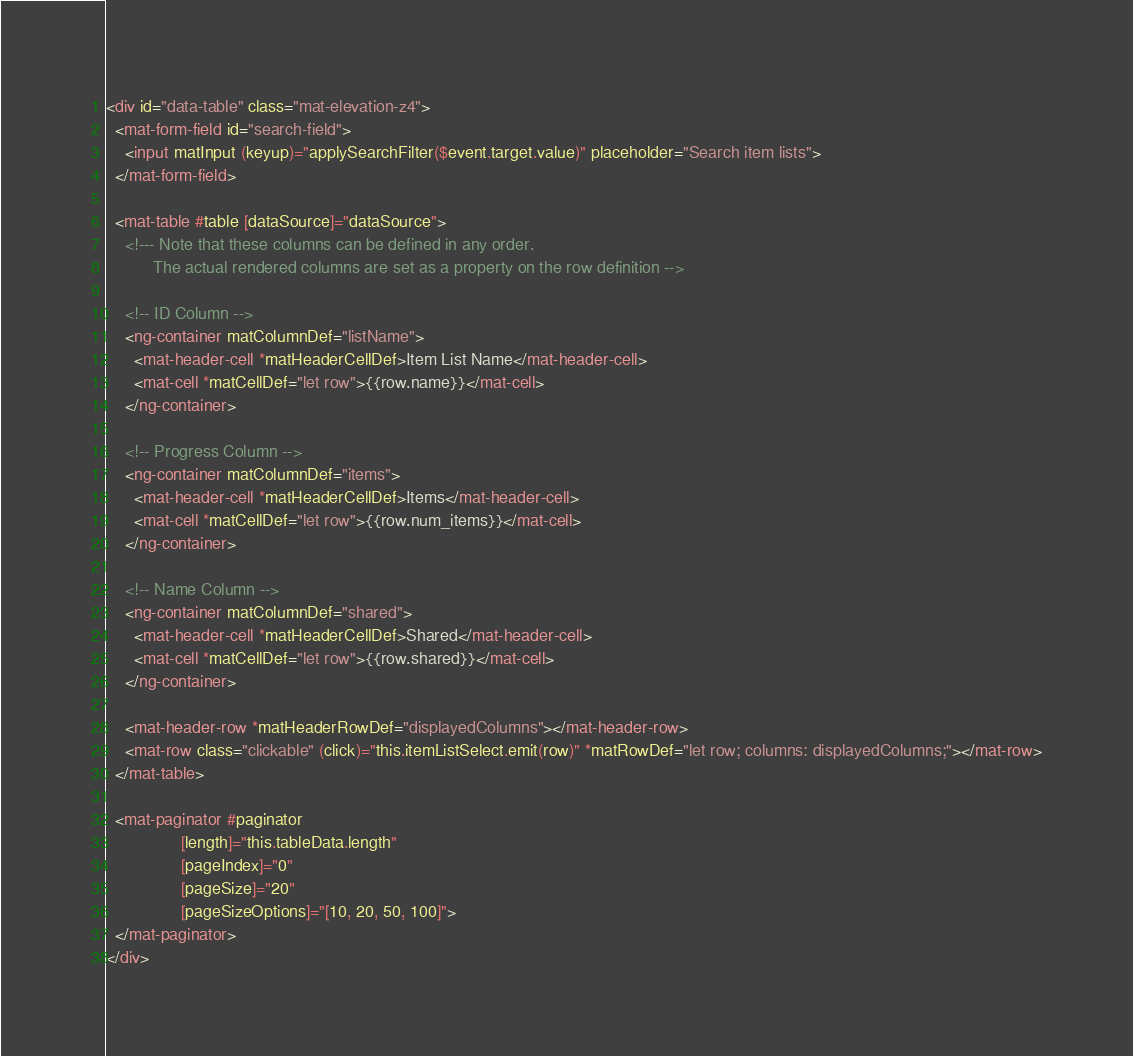Convert code to text. <code><loc_0><loc_0><loc_500><loc_500><_HTML_><div id="data-table" class="mat-elevation-z4">
  <mat-form-field id="search-field">
    <input matInput (keyup)="applySearchFilter($event.target.value)" placeholder="Search item lists">
  </mat-form-field>

  <mat-table #table [dataSource]="dataSource">
    <!--- Note that these columns can be defined in any order.
          The actual rendered columns are set as a property on the row definition -->

    <!-- ID Column -->
    <ng-container matColumnDef="listName">
      <mat-header-cell *matHeaderCellDef>Item List Name</mat-header-cell>
      <mat-cell *matCellDef="let row">{{row.name}}</mat-cell>
    </ng-container>

    <!-- Progress Column -->
    <ng-container matColumnDef="items">
      <mat-header-cell *matHeaderCellDef>Items</mat-header-cell>
      <mat-cell *matCellDef="let row">{{row.num_items}}</mat-cell>
    </ng-container>

    <!-- Name Column -->
    <ng-container matColumnDef="shared">
      <mat-header-cell *matHeaderCellDef>Shared</mat-header-cell>
      <mat-cell *matCellDef="let row">{{row.shared}}</mat-cell>
    </ng-container>

    <mat-header-row *matHeaderRowDef="displayedColumns"></mat-header-row>
    <mat-row class="clickable" (click)="this.itemListSelect.emit(row)" *matRowDef="let row; columns: displayedColumns;"></mat-row>
  </mat-table>

  <mat-paginator #paginator
                [length]="this.tableData.length"
                [pageIndex]="0"
                [pageSize]="20"
                [pageSizeOptions]="[10, 20, 50, 100]">
  </mat-paginator>
</div>
</code> 